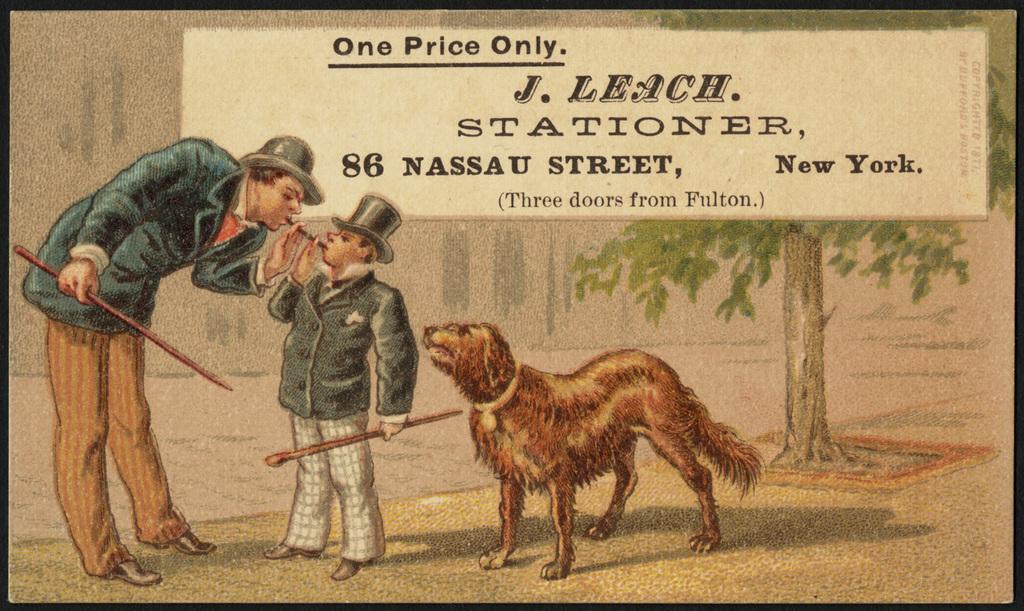Can you describe this image briefly? In this image there is a drawing which consists of two people holding sticks and beside it there is an animal, in the background there is some text written, behind it there is a tree. 